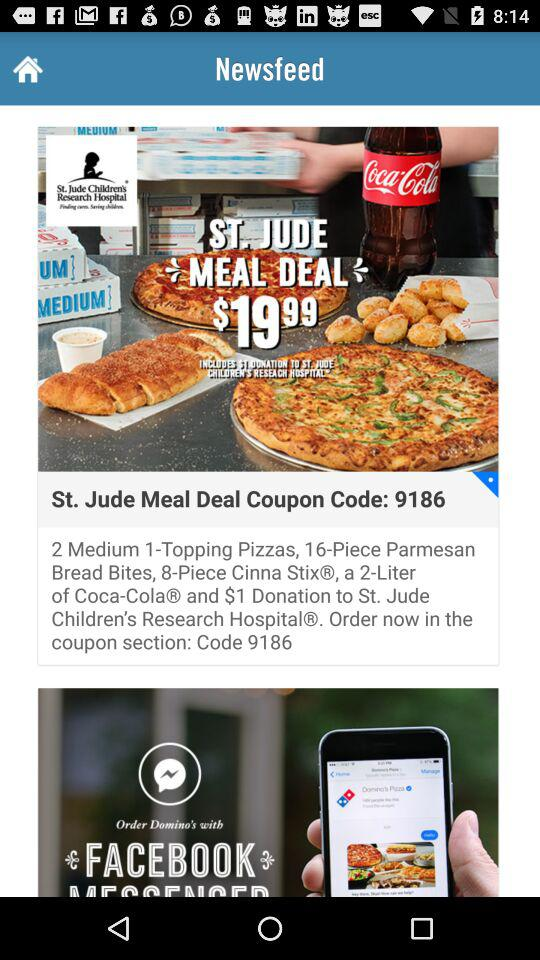What is the coupon code? The coupon code is "9186". 